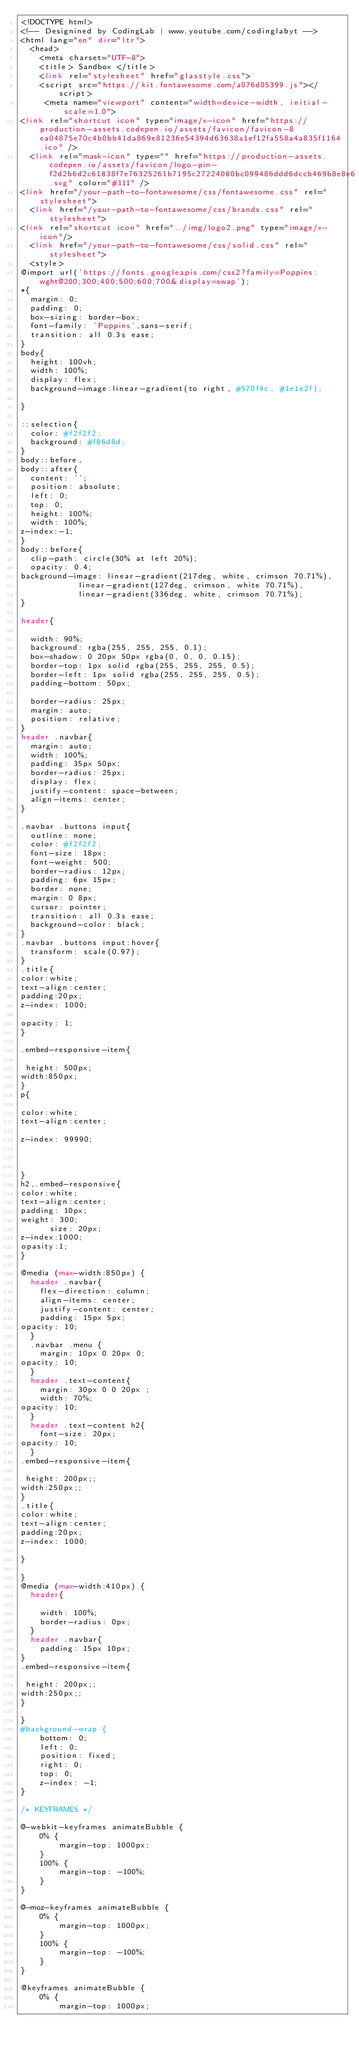<code> <loc_0><loc_0><loc_500><loc_500><_PHP_><!DOCTYPE html>
<!-- Designined by CodingLab | www.youtube.com/codinglabyt -->
<html lang="en" dir="ltr">
  <head>
    <meta charset="UTF-8">
    <title> Sandbox </title>
    <link rel="stylesheet" href="glasstyle.css">
    <script src="https://kit.fontawesome.com/a076d05399.js"></script>
     <meta name="viewport" content="width=device-width, initial-scale=1.0">
<link rel="shortcut icon" type="image/x-icon" href="https://production-assets.codepen.io/assets/favicon/favicon-8ea04875e70c4b0bb41da869e81236e54394d63638a1ef12fa558a4a835f1164.ico" />
  <link rel="mask-icon" type="" href="https://production-assets.codepen.io/assets/favicon/logo-pin-f2d2b6d2c61838f7e76325261b7195c27224080bc099486ddd6dccb469b8e8e6.svg" color="#111" />
<link href="/your-path-to-fontawesome/css/fontawesome.css" rel="stylesheet">
  <link href="/your-path-to-fontawesome/css/brands.css" rel="stylesheet">
<link rel="shortcut icon" href="../img/logo2.png" type="image/x-icon"/>
  <link href="/your-path-to-fontawesome/css/solid.css" rel="stylesheet">
  <style>
@import url('https://fonts.googleapis.com/css2?family=Poppins:wght@200;300;400;500;600;700&display=swap');
*{
  margin: 0;
  padding: 0;
  box-sizing: border-box;
  font-family: 'Poppins',sans-serif;
  transition: all 0.3s ease;
}
body{
  height: 100vh;
  width: 100%;
  display: flex;
  background-image:linear-gradient(to right, #570f4c, #1e1e2f);

}

::selection{
  color: #f2f2f2;
  background: #f86d8d;
}
body::before,
body::after{
  content: '';
  position: absolute;
  left: 0;
  top: 0;
  height: 100%;
  width: 100%;
z-index:-1;
}
body::before{
  clip-path: circle(30% at left 20%);
  opacity: 0.4;
background-image: linear-gradient(217deg, white, crimson 70.71%),
            linear-gradient(127deg, crimson, white 70.71%),
            linear-gradient(336deg, white, crimson 70.71%);
}

header{
  
  width: 90%;
  background: rgba(255, 255, 255, 0.1);
  box-shadow: 0 20px 50px rgba(0, 0, 0, 0.15);
  border-top: 1px solid rgba(255, 255, 255, 0.5);
  border-left: 1px solid rgba(255, 255, 255, 0.5);
  padding-bottom: 50px;
 
  border-radius: 25px;
  margin: auto;
  position: relative;
}
header .navbar{
  margin: auto;
  width: 100%;
  padding: 35px 50px;
  border-radius: 25px;
  display: flex;
  justify-content: space-between;
  align-items: center;
}

.navbar .buttons input{
  outline: none;
  color: #f2f2f2;
  font-size: 18px;
  font-weight: 500;
  border-radius: 12px;
  padding: 6px 15px;
  border: none;
  margin: 0 8px;
  cursor: pointer;
  transition: all 0.3s ease;
  background-color: black;
}
.navbar .buttons input:hover{
  transform: scale(0.97);
}
.title{
color:white;
text-align:center;
padding:20px;
z-index: 1000;

opacity: 1;
}

.embed-responsive-item{

 height: 500px;
width:850px;
}
p{

color:white;
text-align:center;

z-index: 99990;



}
h2,.embed-responsive{
color:white;
text-align:center;
padding: 10px;
weight: 300;
      size: 20px;
z-index:1000;
opasity:1;
}

@media (max-width:850px) {
  header .navbar{
    flex-direction: column;
    align-items: center;
    justify-content: center;
    padding: 15px 5px;
opacity: 10;
  }
  .navbar .menu {
    margin: 10px 0 20px 0;
opacity: 10;
  }
  header .text-content{
    margin: 30px 0 0 20px ;
    width: 70%;
opacity: 10;
  }
  header .text-content h2{
    font-size: 20px;
opacity: 10;
  }
.embed-responsive-item{

 height: 200px;;
width:250px;;
}
.title{
color:white;
text-align:center;
padding:20px;
z-index: 1000;

}

}
@media (max-width:410px) {
  header{
    
    width: 100%;
    border-radius: 0px;
  }
  header .navbar{
    padding: 15px 10px;
}
.embed-responsive-item{

 height: 200px;;
width:250px;;
}

}
#background-wrap {
    bottom: 0;
	left: 0;
	position: fixed;
	right: 0;
	top: 0;
	z-index: -1;
}

/* KEYFRAMES */

@-webkit-keyframes animateBubble {
    0% {
        margin-top: 1000px;
    }
    100% {
        margin-top: -100%;
    }
}

@-moz-keyframes animateBubble {
    0% {
        margin-top: 1000px;
    }
    100% {
        margin-top: -100%;
    }
}

@keyframes animateBubble {
    0% {
        margin-top: 1000px;</code> 